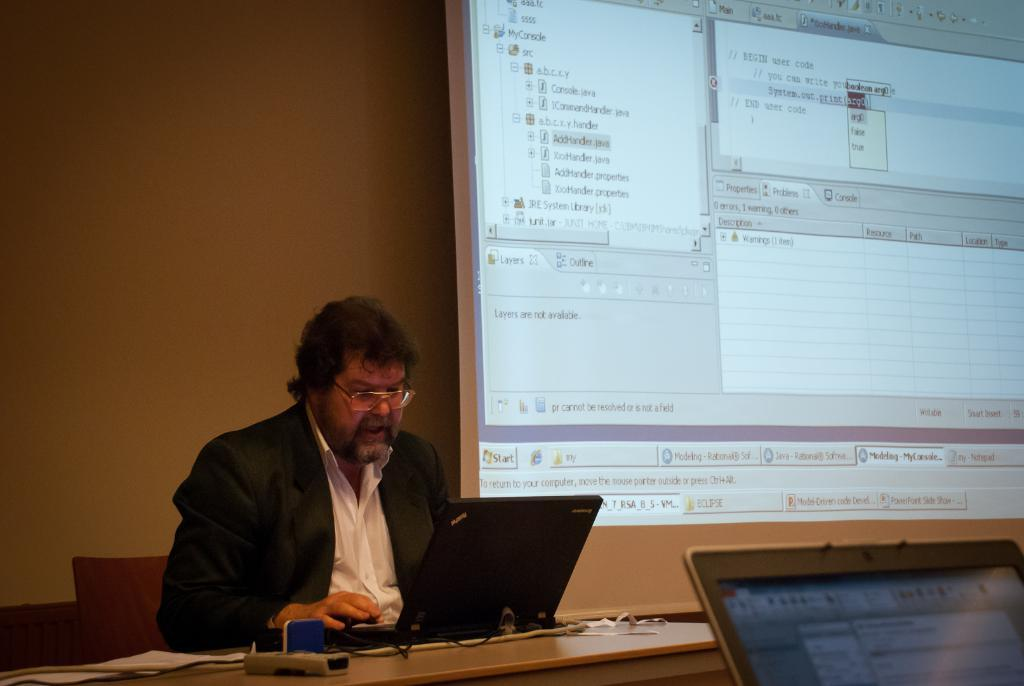What is the person in the image doing? The person is operating a laptop. What is the person wearing in the image? The person is wearing a black suit. What is the person's position in the image? The person is sitting on a chair. What is present at the right side of the image? There is a projector screen at the right side of the image. Can you see the moon in the image? No, the moon is not present in the image. Is the person kicking a ball in the image? No, the person is not kicking a ball in the image; they are sitting on a chair and operating a laptop. 